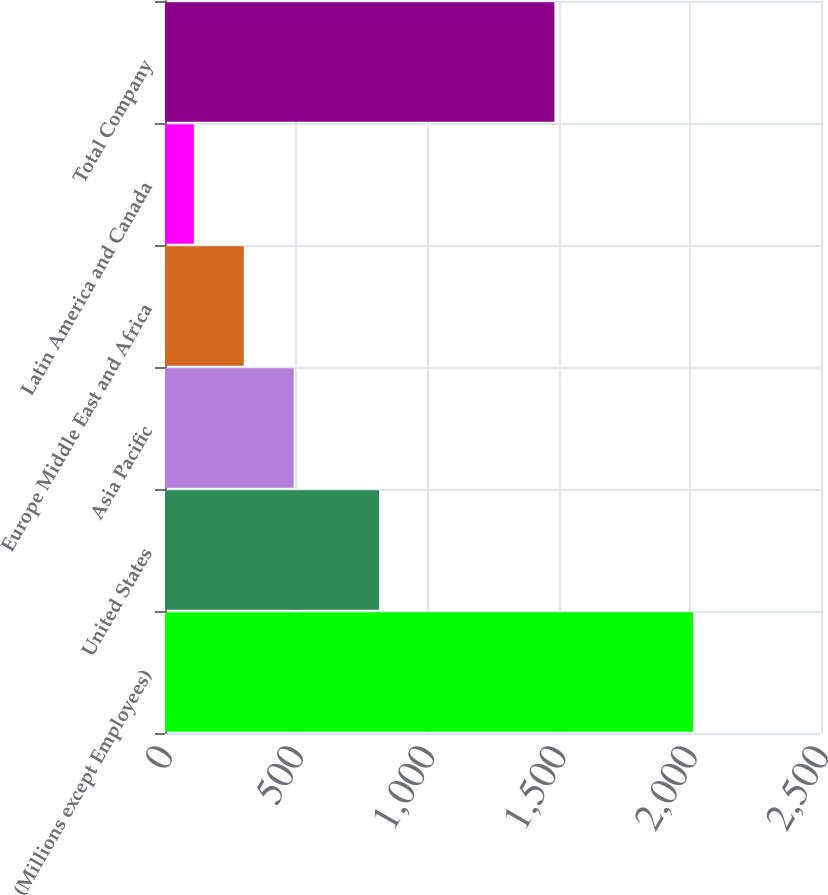Convert chart. <chart><loc_0><loc_0><loc_500><loc_500><bar_chart><fcel>(Millions except Employees)<fcel>United States<fcel>Asia Pacific<fcel>Europe Middle East and Africa<fcel>Latin America and Canada<fcel>Total Company<nl><fcel>2012<fcel>816<fcel>490.4<fcel>300.2<fcel>110<fcel>1484<nl></chart> 